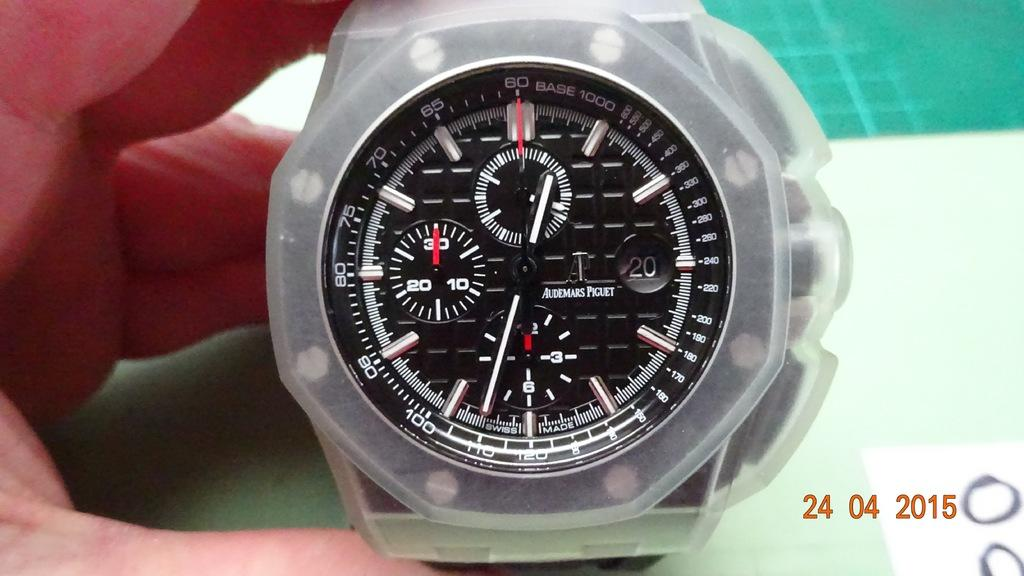<image>
Offer a succinct explanation of the picture presented. An Audemars Piguet watch is held up by a hand 